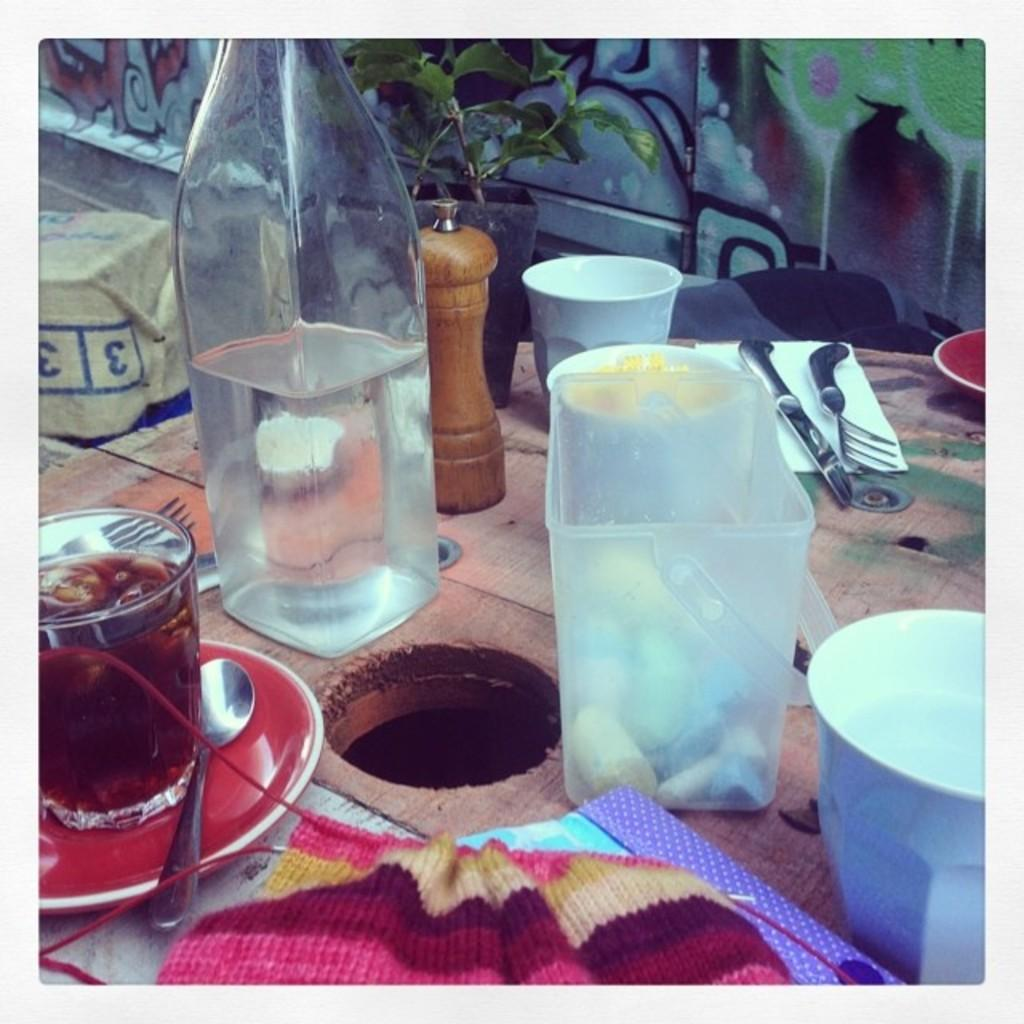What piece of furniture is present in the image? There is a table in the image. What is placed on the table? There is a bottle, glasses, a box, a knife, a fork, and a cloth on the table. Can you describe the plant in the image? There is a plant in the image, but no specific details about its appearance are provided. Are there any other objects on the table that are not mentioned? Yes, there are other unspecified objects on the table. What type of temper is the system displaying in the image? There is no system or temper present in the image; it features a table with various objects and a plant. How is the growth of the plant being affected by the objects on the table? The growth of the plant is not mentioned or depicted in the image, so it cannot be determined how it might be affected by the objects on the table. 